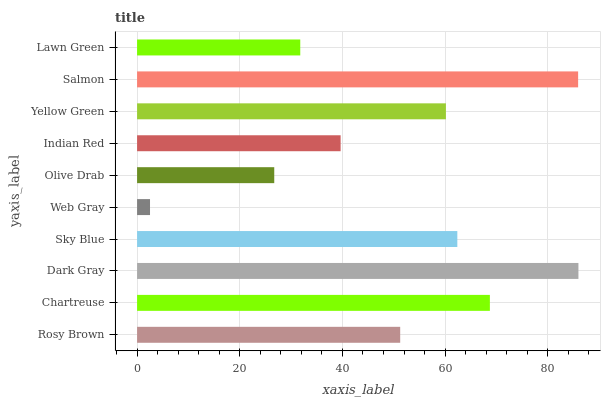Is Web Gray the minimum?
Answer yes or no. Yes. Is Dark Gray the maximum?
Answer yes or no. Yes. Is Chartreuse the minimum?
Answer yes or no. No. Is Chartreuse the maximum?
Answer yes or no. No. Is Chartreuse greater than Rosy Brown?
Answer yes or no. Yes. Is Rosy Brown less than Chartreuse?
Answer yes or no. Yes. Is Rosy Brown greater than Chartreuse?
Answer yes or no. No. Is Chartreuse less than Rosy Brown?
Answer yes or no. No. Is Yellow Green the high median?
Answer yes or no. Yes. Is Rosy Brown the low median?
Answer yes or no. Yes. Is Lawn Green the high median?
Answer yes or no. No. Is Web Gray the low median?
Answer yes or no. No. 